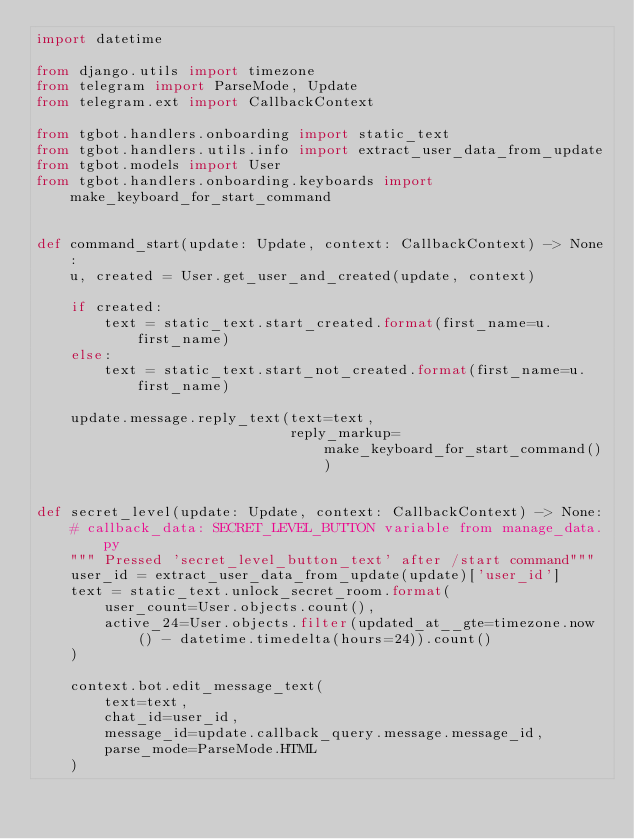<code> <loc_0><loc_0><loc_500><loc_500><_Python_>import datetime

from django.utils import timezone
from telegram import ParseMode, Update
from telegram.ext import CallbackContext

from tgbot.handlers.onboarding import static_text
from tgbot.handlers.utils.info import extract_user_data_from_update
from tgbot.models import User
from tgbot.handlers.onboarding.keyboards import make_keyboard_for_start_command


def command_start(update: Update, context: CallbackContext) -> None:
    u, created = User.get_user_and_created(update, context)

    if created:
        text = static_text.start_created.format(first_name=u.first_name)
    else:
        text = static_text.start_not_created.format(first_name=u.first_name)

    update.message.reply_text(text=text,
                              reply_markup=make_keyboard_for_start_command())


def secret_level(update: Update, context: CallbackContext) -> None:
    # callback_data: SECRET_LEVEL_BUTTON variable from manage_data.py
    """ Pressed 'secret_level_button_text' after /start command"""
    user_id = extract_user_data_from_update(update)['user_id']
    text = static_text.unlock_secret_room.format(
        user_count=User.objects.count(),
        active_24=User.objects.filter(updated_at__gte=timezone.now() - datetime.timedelta(hours=24)).count()
    )

    context.bot.edit_message_text(
        text=text,
        chat_id=user_id,
        message_id=update.callback_query.message.message_id,
        parse_mode=ParseMode.HTML
    )
</code> 